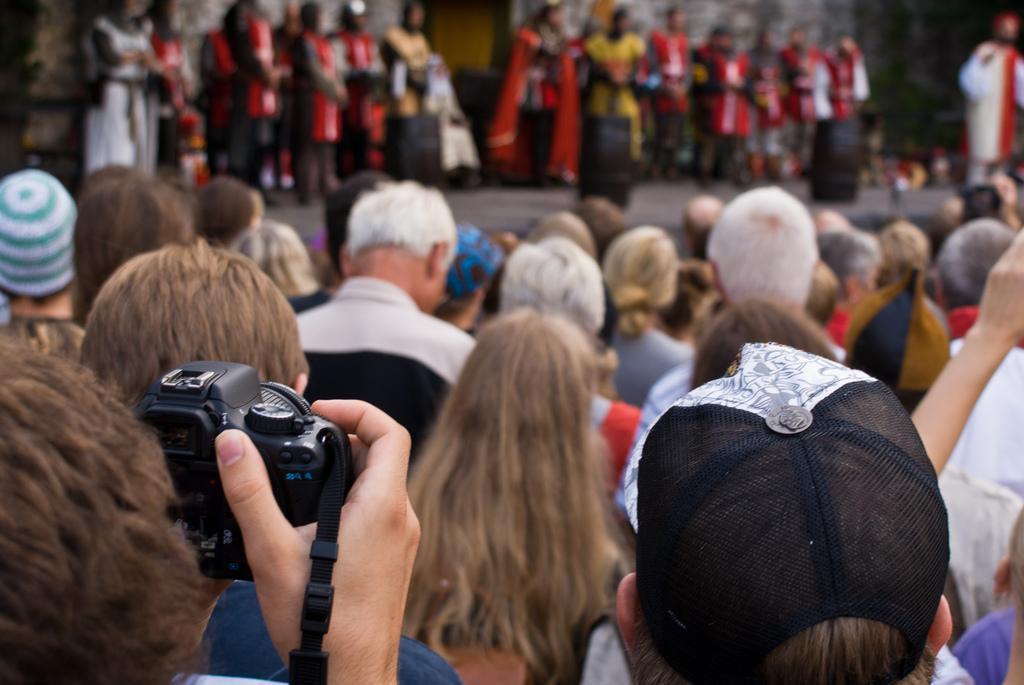In one or two sentences, can you explain what this image depicts? In this picture I can see group of people are standing. This person is holding a camera in the hand. 